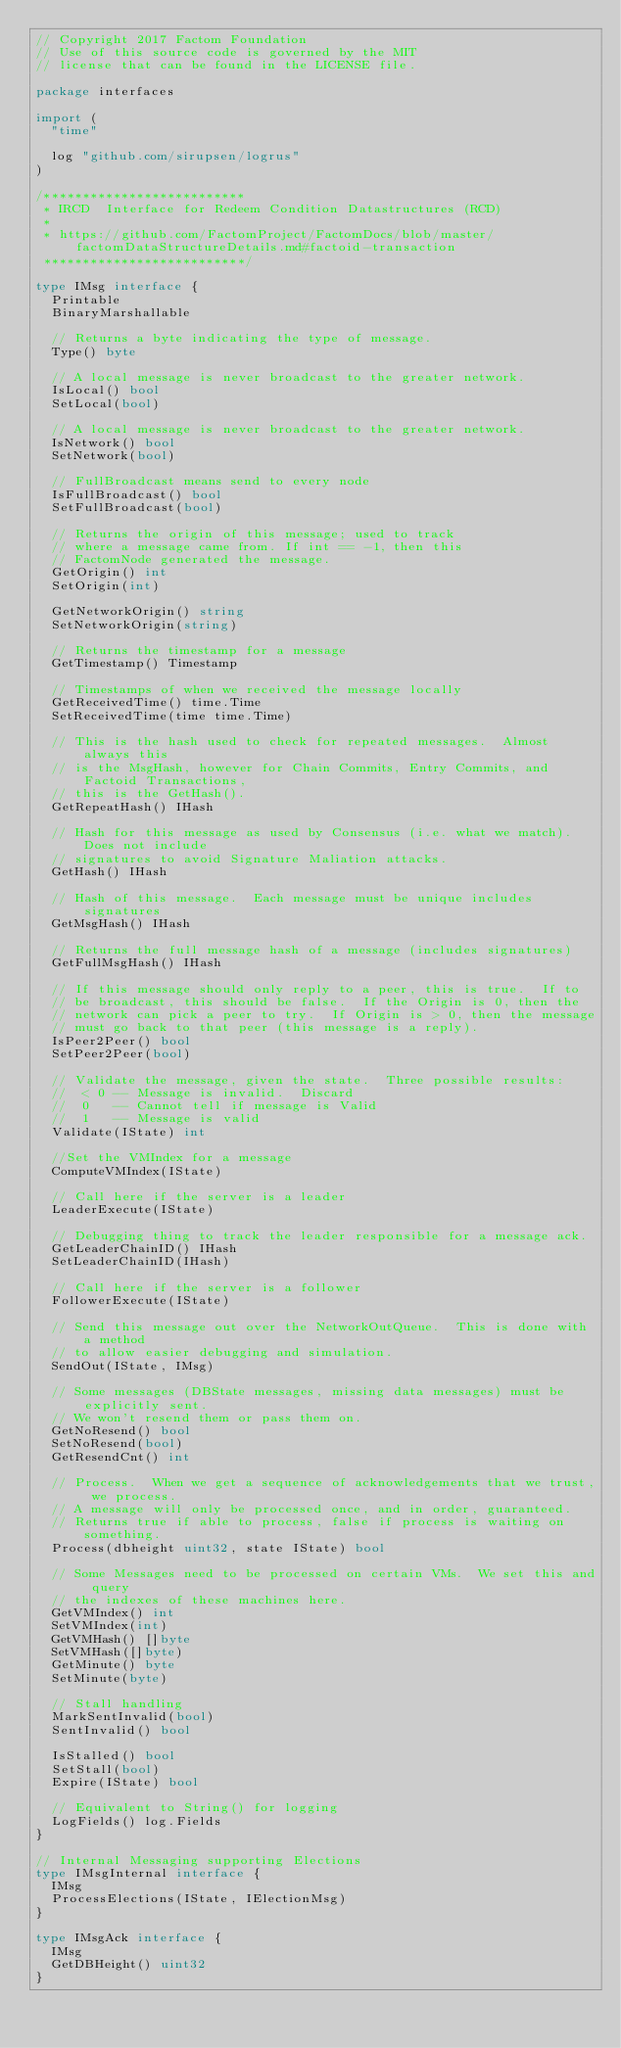Convert code to text. <code><loc_0><loc_0><loc_500><loc_500><_Go_>// Copyright 2017 Factom Foundation
// Use of this source code is governed by the MIT
// license that can be found in the LICENSE file.

package interfaces

import (
	"time"

	log "github.com/sirupsen/logrus"
)

/**************************
 * IRCD  Interface for Redeem Condition Datastructures (RCD)
 *
 * https://github.com/FactomProject/FactomDocs/blob/master/factomDataStructureDetails.md#factoid-transaction
 **************************/

type IMsg interface {
	Printable
	BinaryMarshallable

	// Returns a byte indicating the type of message.
	Type() byte

	// A local message is never broadcast to the greater network.
	IsLocal() bool
	SetLocal(bool)

	// A local message is never broadcast to the greater network.
	IsNetwork() bool
	SetNetwork(bool)

	// FullBroadcast means send to every node
	IsFullBroadcast() bool
	SetFullBroadcast(bool)

	// Returns the origin of this message; used to track
	// where a message came from. If int == -1, then this
	// FactomNode generated the message.
	GetOrigin() int
	SetOrigin(int)

	GetNetworkOrigin() string
	SetNetworkOrigin(string)

	// Returns the timestamp for a message
	GetTimestamp() Timestamp

	// Timestamps of when we received the message locally
	GetReceivedTime() time.Time
	SetReceivedTime(time time.Time)

	// This is the hash used to check for repeated messages.  Almost always this
	// is the MsgHash, however for Chain Commits, Entry Commits, and Factoid Transactions,
	// this is the GetHash().
	GetRepeatHash() IHash

	// Hash for this message as used by Consensus (i.e. what we match). Does not include
	// signatures to avoid Signature Maliation attacks.
	GetHash() IHash

	// Hash of this message.  Each message must be unique includes signatures
	GetMsgHash() IHash

	// Returns the full message hash of a message (includes signatures)
	GetFullMsgHash() IHash

	// If this message should only reply to a peer, this is true.  If to
	// be broadcast, this should be false.  If the Origin is 0, then the
	// network can pick a peer to try.  If Origin is > 0, then the message
	// must go back to that peer (this message is a reply).
	IsPeer2Peer() bool
	SetPeer2Peer(bool)

	// Validate the message, given the state.  Three possible results:
	//  < 0 -- Message is invalid.  Discard
	//  0   -- Cannot tell if message is Valid
	//  1   -- Message is valid
	Validate(IState) int

	//Set the VMIndex for a message
	ComputeVMIndex(IState)

	// Call here if the server is a leader
	LeaderExecute(IState)

	// Debugging thing to track the leader responsible for a message ack.
	GetLeaderChainID() IHash
	SetLeaderChainID(IHash)

	// Call here if the server is a follower
	FollowerExecute(IState)

	// Send this message out over the NetworkOutQueue.  This is done with a method
	// to allow easier debugging and simulation.
	SendOut(IState, IMsg)

	// Some messages (DBState messages, missing data messages) must be explicitly sent.
	// We won't resend them or pass them on.
	GetNoResend() bool
	SetNoResend(bool)
	GetResendCnt() int

	// Process.  When we get a sequence of acknowledgements that we trust, we process.
	// A message will only be processed once, and in order, guaranteed.
	// Returns true if able to process, false if process is waiting on something.
	Process(dbheight uint32, state IState) bool

	// Some Messages need to be processed on certain VMs.  We set this and query
	// the indexes of these machines here.
	GetVMIndex() int
	SetVMIndex(int)
	GetVMHash() []byte
	SetVMHash([]byte)
	GetMinute() byte
	SetMinute(byte)

	// Stall handling
	MarkSentInvalid(bool)
	SentInvalid() bool

	IsStalled() bool
	SetStall(bool)
	Expire(IState) bool

	// Equivalent to String() for logging
	LogFields() log.Fields
}

// Internal Messaging supporting Elections
type IMsgInternal interface {
	IMsg
	ProcessElections(IState, IElectionMsg)
}

type IMsgAck interface {
	IMsg
	GetDBHeight() uint32
}
</code> 